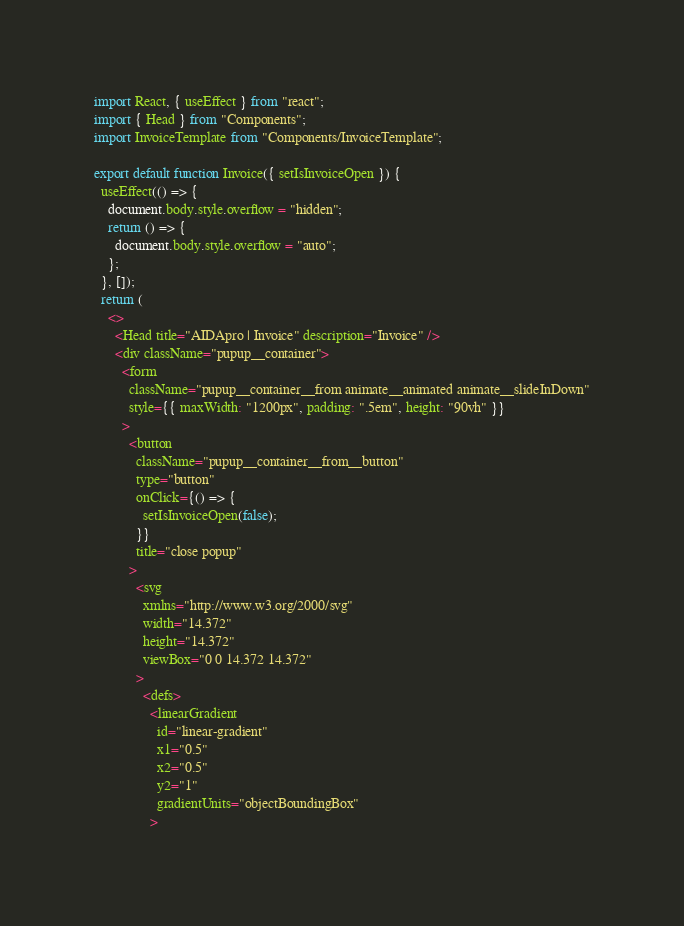<code> <loc_0><loc_0><loc_500><loc_500><_JavaScript_>import React, { useEffect } from "react";
import { Head } from "Components";
import InvoiceTemplate from "Components/InvoiceTemplate";

export default function Invoice({ setIsInvoiceOpen }) {
  useEffect(() => {
    document.body.style.overflow = "hidden";
    return () => {
      document.body.style.overflow = "auto";
    };
  }, []);
  return (
    <>
      <Head title="AIDApro | Invoice" description="Invoice" />
      <div className="pupup__container">
        <form
          className="pupup__container__from animate__animated animate__slideInDown"
          style={{ maxWidth: "1200px", padding: ".5em", height: "90vh" }}
        >
          <button
            className="pupup__container__from__button"
            type="button"
            onClick={() => {
              setIsInvoiceOpen(false);
            }}
            title="close popup"
          >
            <svg
              xmlns="http://www.w3.org/2000/svg"
              width="14.372"
              height="14.372"
              viewBox="0 0 14.372 14.372"
            >
              <defs>
                <linearGradient
                  id="linear-gradient"
                  x1="0.5"
                  x2="0.5"
                  y2="1"
                  gradientUnits="objectBoundingBox"
                ></code> 